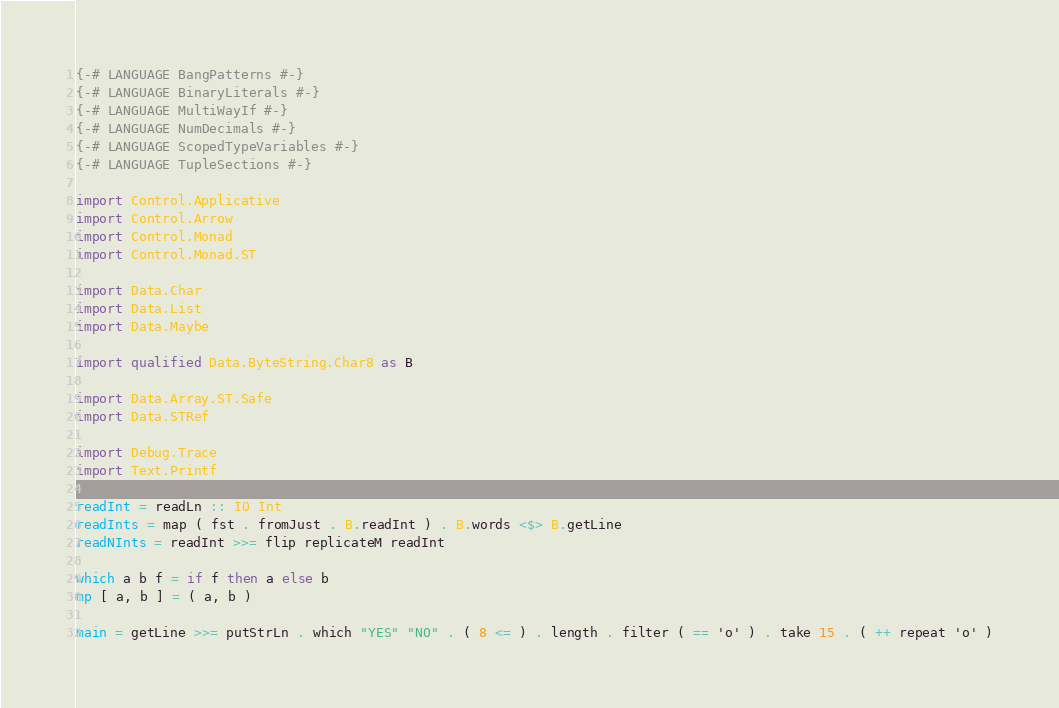Convert code to text. <code><loc_0><loc_0><loc_500><loc_500><_Haskell_>{-# LANGUAGE BangPatterns #-}
{-# LANGUAGE BinaryLiterals #-}
{-# LANGUAGE MultiWayIf #-}
{-# LANGUAGE NumDecimals #-}
{-# LANGUAGE ScopedTypeVariables #-}
{-# LANGUAGE TupleSections #-}

import Control.Applicative
import Control.Arrow
import Control.Monad
import Control.Monad.ST

import Data.Char
import Data.List
import Data.Maybe

import qualified Data.ByteString.Char8 as B

import Data.Array.ST.Safe
import Data.STRef

import Debug.Trace
import Text.Printf

readInt = readLn :: IO Int
readInts = map ( fst . fromJust . B.readInt ) . B.words <$> B.getLine
readNInts = readInt >>= flip replicateM readInt

which a b f = if f then a else b
mp [ a, b ] = ( a, b )

main = getLine >>= putStrLn . which "YES" "NO" . ( 8 <= ) . length . filter ( == 'o' ) . take 15 . ( ++ repeat 'o' )</code> 